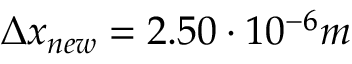<formula> <loc_0><loc_0><loc_500><loc_500>\Delta x _ { n e w } = 2 . 5 0 \cdot 1 0 ^ { - 6 } m</formula> 